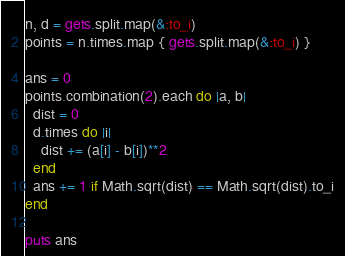Convert code to text. <code><loc_0><loc_0><loc_500><loc_500><_Ruby_>n, d = gets.split.map(&:to_i)
points = n.times.map { gets.split.map(&:to_i) }

ans = 0
points.combination(2).each do |a, b|
  dist = 0
  d.times do |i|
    dist += (a[i] - b[i])**2
  end
  ans += 1 if Math.sqrt(dist) == Math.sqrt(dist).to_i
end

puts ans
</code> 